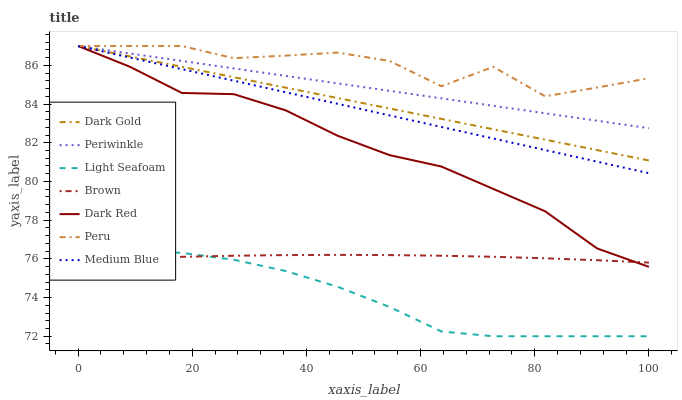Does Light Seafoam have the minimum area under the curve?
Answer yes or no. Yes. Does Peru have the maximum area under the curve?
Answer yes or no. Yes. Does Dark Gold have the minimum area under the curve?
Answer yes or no. No. Does Dark Gold have the maximum area under the curve?
Answer yes or no. No. Is Periwinkle the smoothest?
Answer yes or no. Yes. Is Peru the roughest?
Answer yes or no. Yes. Is Dark Gold the smoothest?
Answer yes or no. No. Is Dark Gold the roughest?
Answer yes or no. No. Does Light Seafoam have the lowest value?
Answer yes or no. Yes. Does Dark Gold have the lowest value?
Answer yes or no. No. Does Peru have the highest value?
Answer yes or no. Yes. Does Light Seafoam have the highest value?
Answer yes or no. No. Is Brown less than Dark Gold?
Answer yes or no. Yes. Is Dark Gold greater than Brown?
Answer yes or no. Yes. Does Dark Gold intersect Periwinkle?
Answer yes or no. Yes. Is Dark Gold less than Periwinkle?
Answer yes or no. No. Is Dark Gold greater than Periwinkle?
Answer yes or no. No. Does Brown intersect Dark Gold?
Answer yes or no. No. 